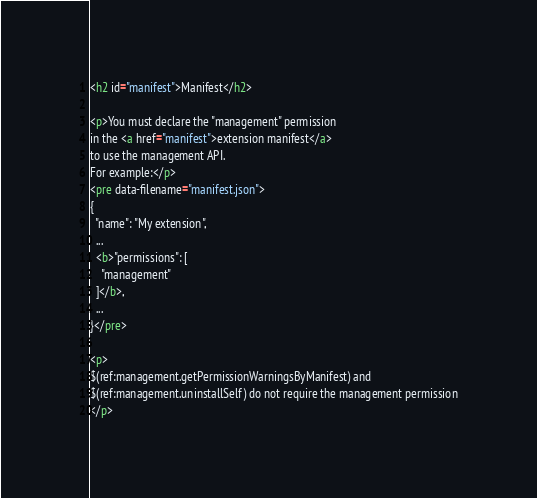<code> <loc_0><loc_0><loc_500><loc_500><_HTML_><h2 id="manifest">Manifest</h2>

<p>You must declare the "management" permission
in the <a href="manifest">extension manifest</a>
to use the management API.
For example:</p>
<pre data-filename="manifest.json">
{
  "name": "My extension",
  ...
  <b>"permissions": [
    "management"
  ]</b>,
  ...
}</pre>

<p>
$(ref:management.getPermissionWarningsByManifest) and
$(ref:management.uninstallSelf) do not require the management permission
</p>
</code> 